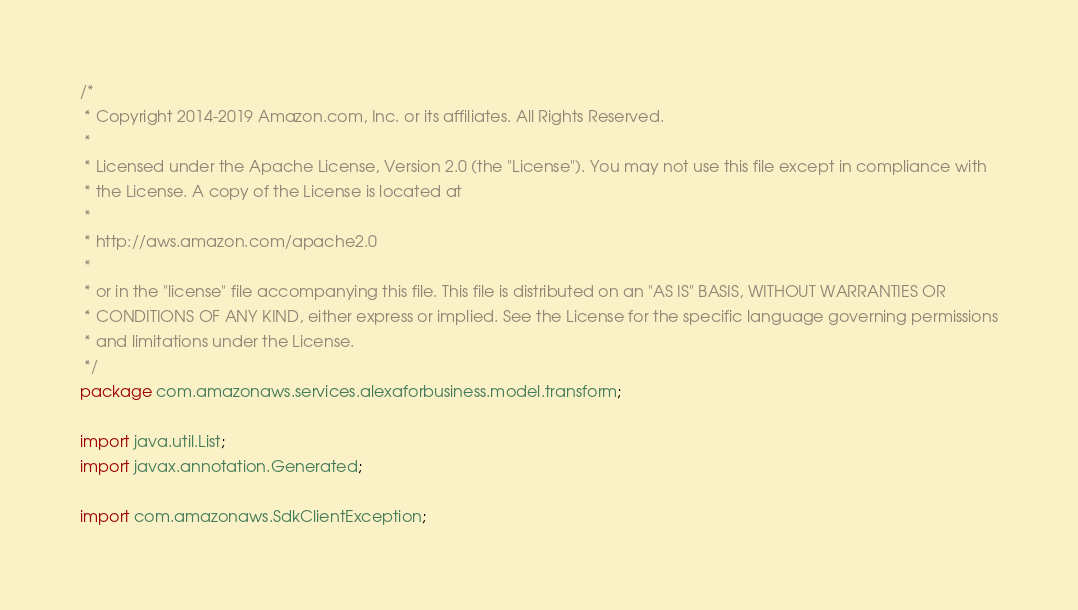Convert code to text. <code><loc_0><loc_0><loc_500><loc_500><_Java_>/*
 * Copyright 2014-2019 Amazon.com, Inc. or its affiliates. All Rights Reserved.
 * 
 * Licensed under the Apache License, Version 2.0 (the "License"). You may not use this file except in compliance with
 * the License. A copy of the License is located at
 * 
 * http://aws.amazon.com/apache2.0
 * 
 * or in the "license" file accompanying this file. This file is distributed on an "AS IS" BASIS, WITHOUT WARRANTIES OR
 * CONDITIONS OF ANY KIND, either express or implied. See the License for the specific language governing permissions
 * and limitations under the License.
 */
package com.amazonaws.services.alexaforbusiness.model.transform;

import java.util.List;
import javax.annotation.Generated;

import com.amazonaws.SdkClientException;</code> 